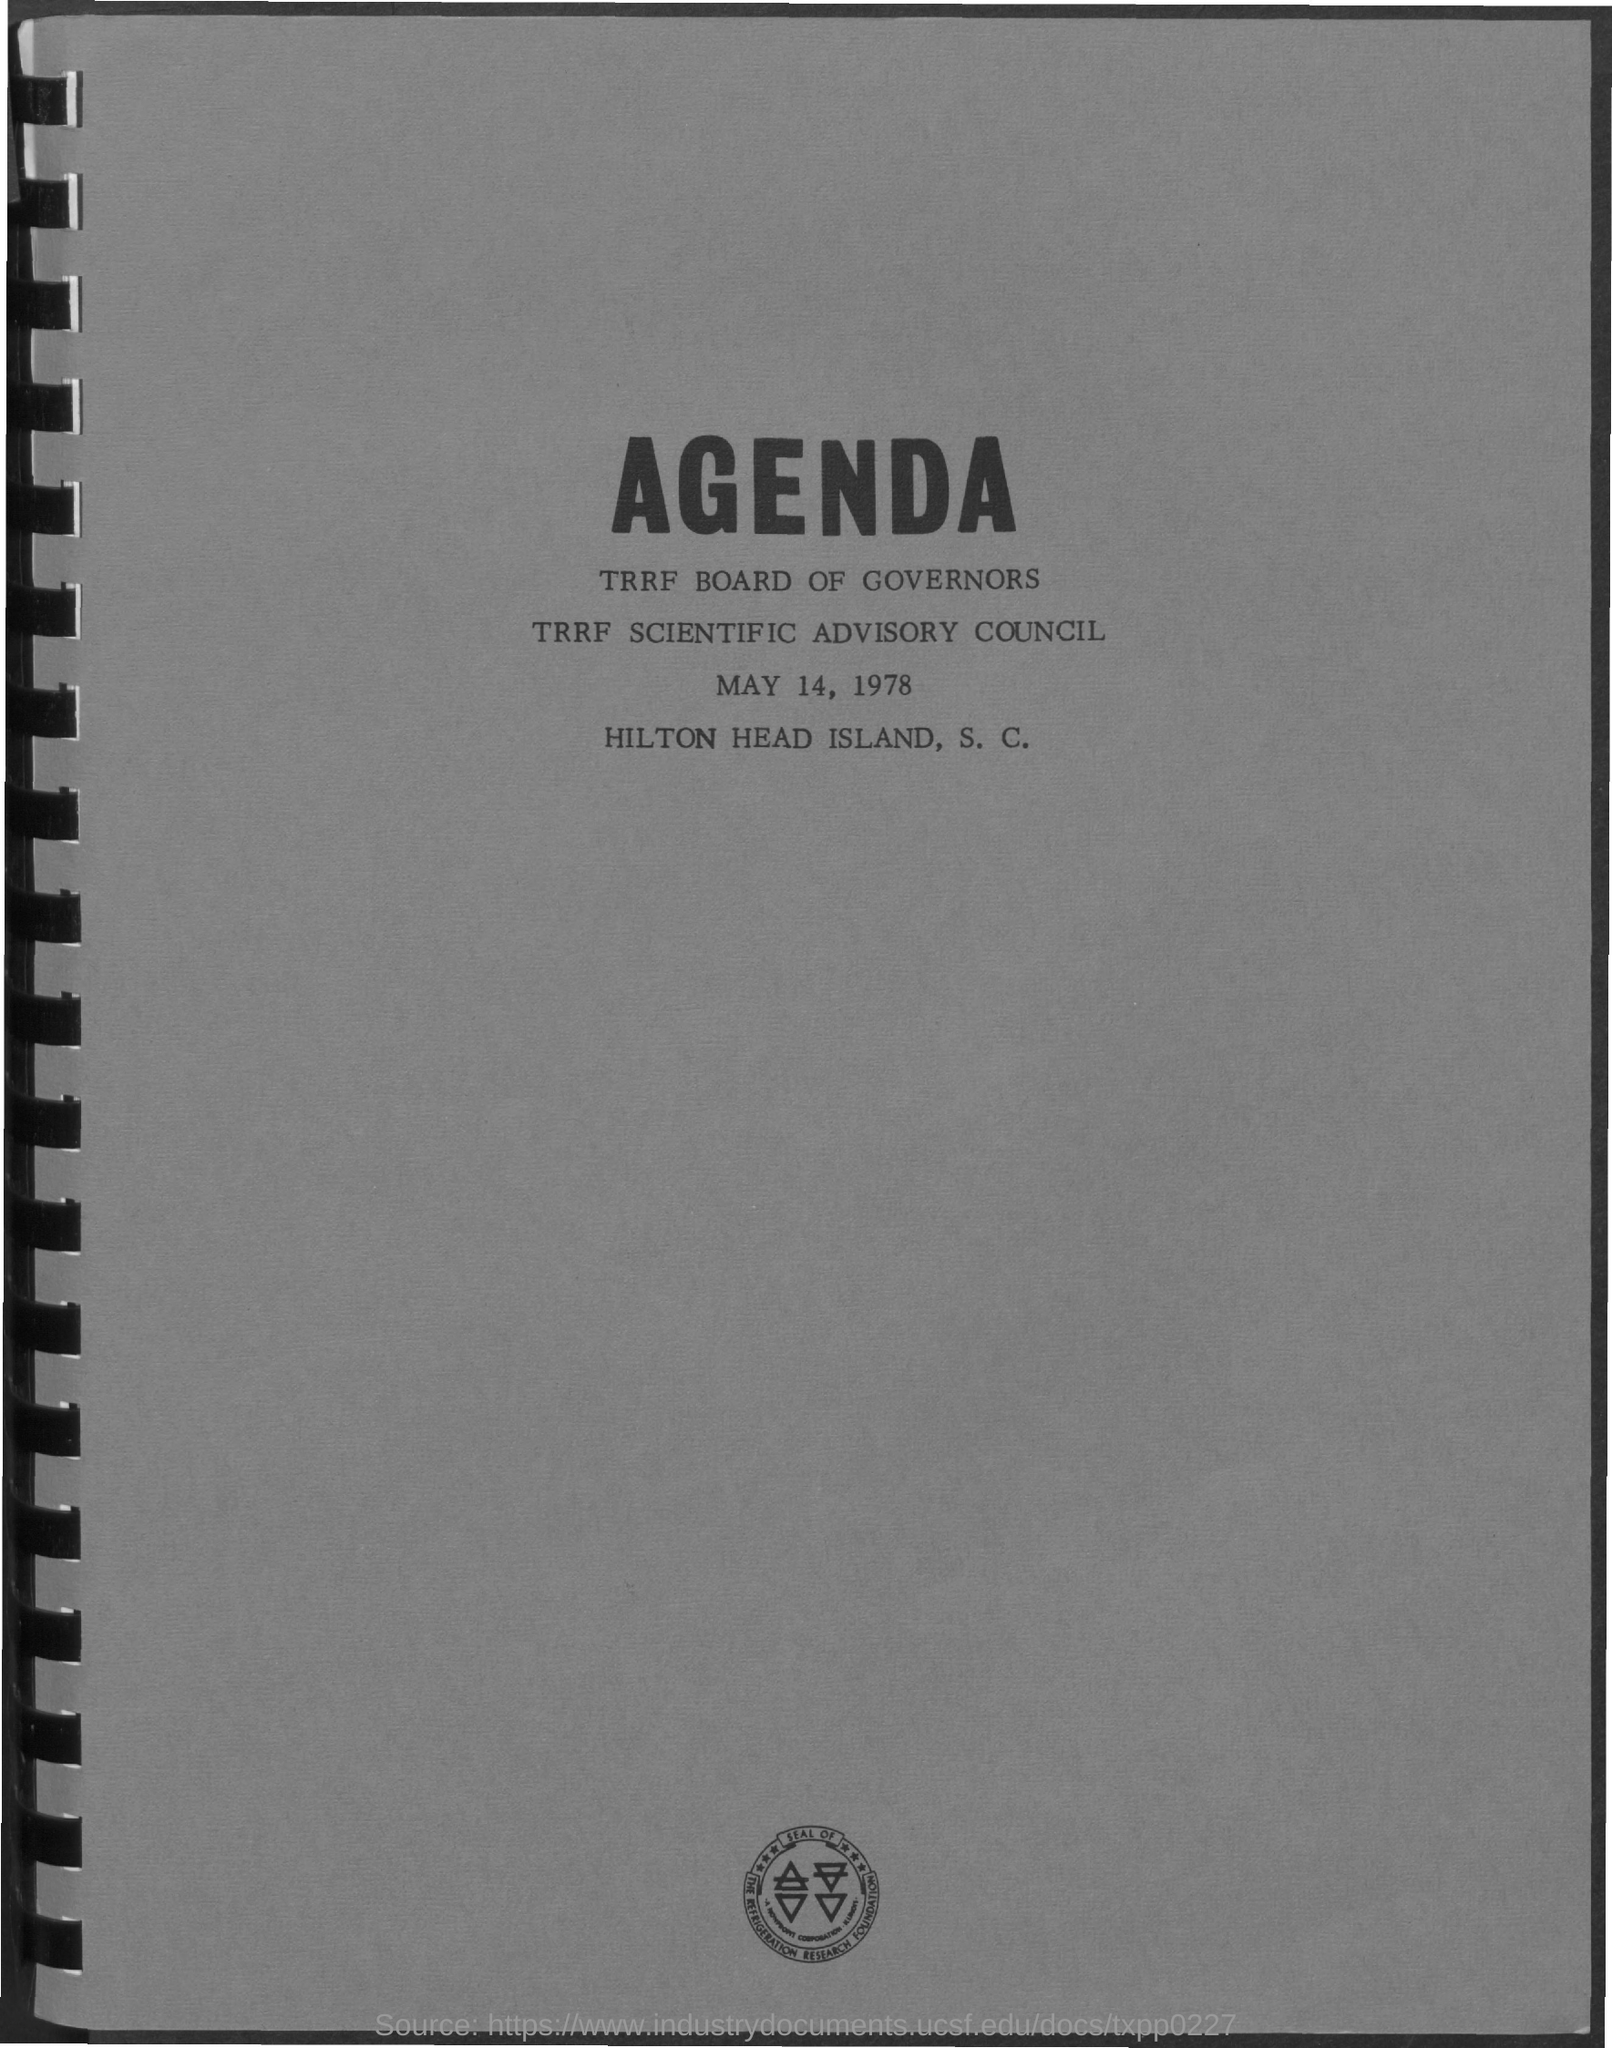Point out several critical features in this image. The date on the document is May 14, 1978. 